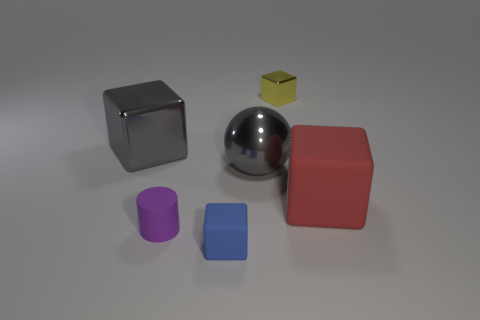Is the size of the purple cylinder the same as the yellow cube?
Give a very brief answer. Yes. There is a tiny thing behind the big rubber cube; what is its material?
Ensure brevity in your answer.  Metal. There is a gray thing that is the same shape as the yellow thing; what material is it?
Your answer should be very brief. Metal. There is a small block that is behind the big matte block; are there any matte objects that are right of it?
Ensure brevity in your answer.  Yes. Do the large matte object and the tiny metal object have the same shape?
Your answer should be compact. Yes. There is a blue thing that is the same material as the large red cube; what shape is it?
Give a very brief answer. Cube. There is a cube right of the yellow metal thing; is it the same size as the metallic block to the right of the tiny rubber block?
Keep it short and to the point. No. Is the number of big gray balls on the left side of the large matte block greater than the number of large gray spheres behind the gray sphere?
Your answer should be compact. Yes. How many other objects are the same color as the metallic ball?
Ensure brevity in your answer.  1. Do the big metal sphere and the cube that is to the left of the blue thing have the same color?
Your answer should be very brief. Yes. 